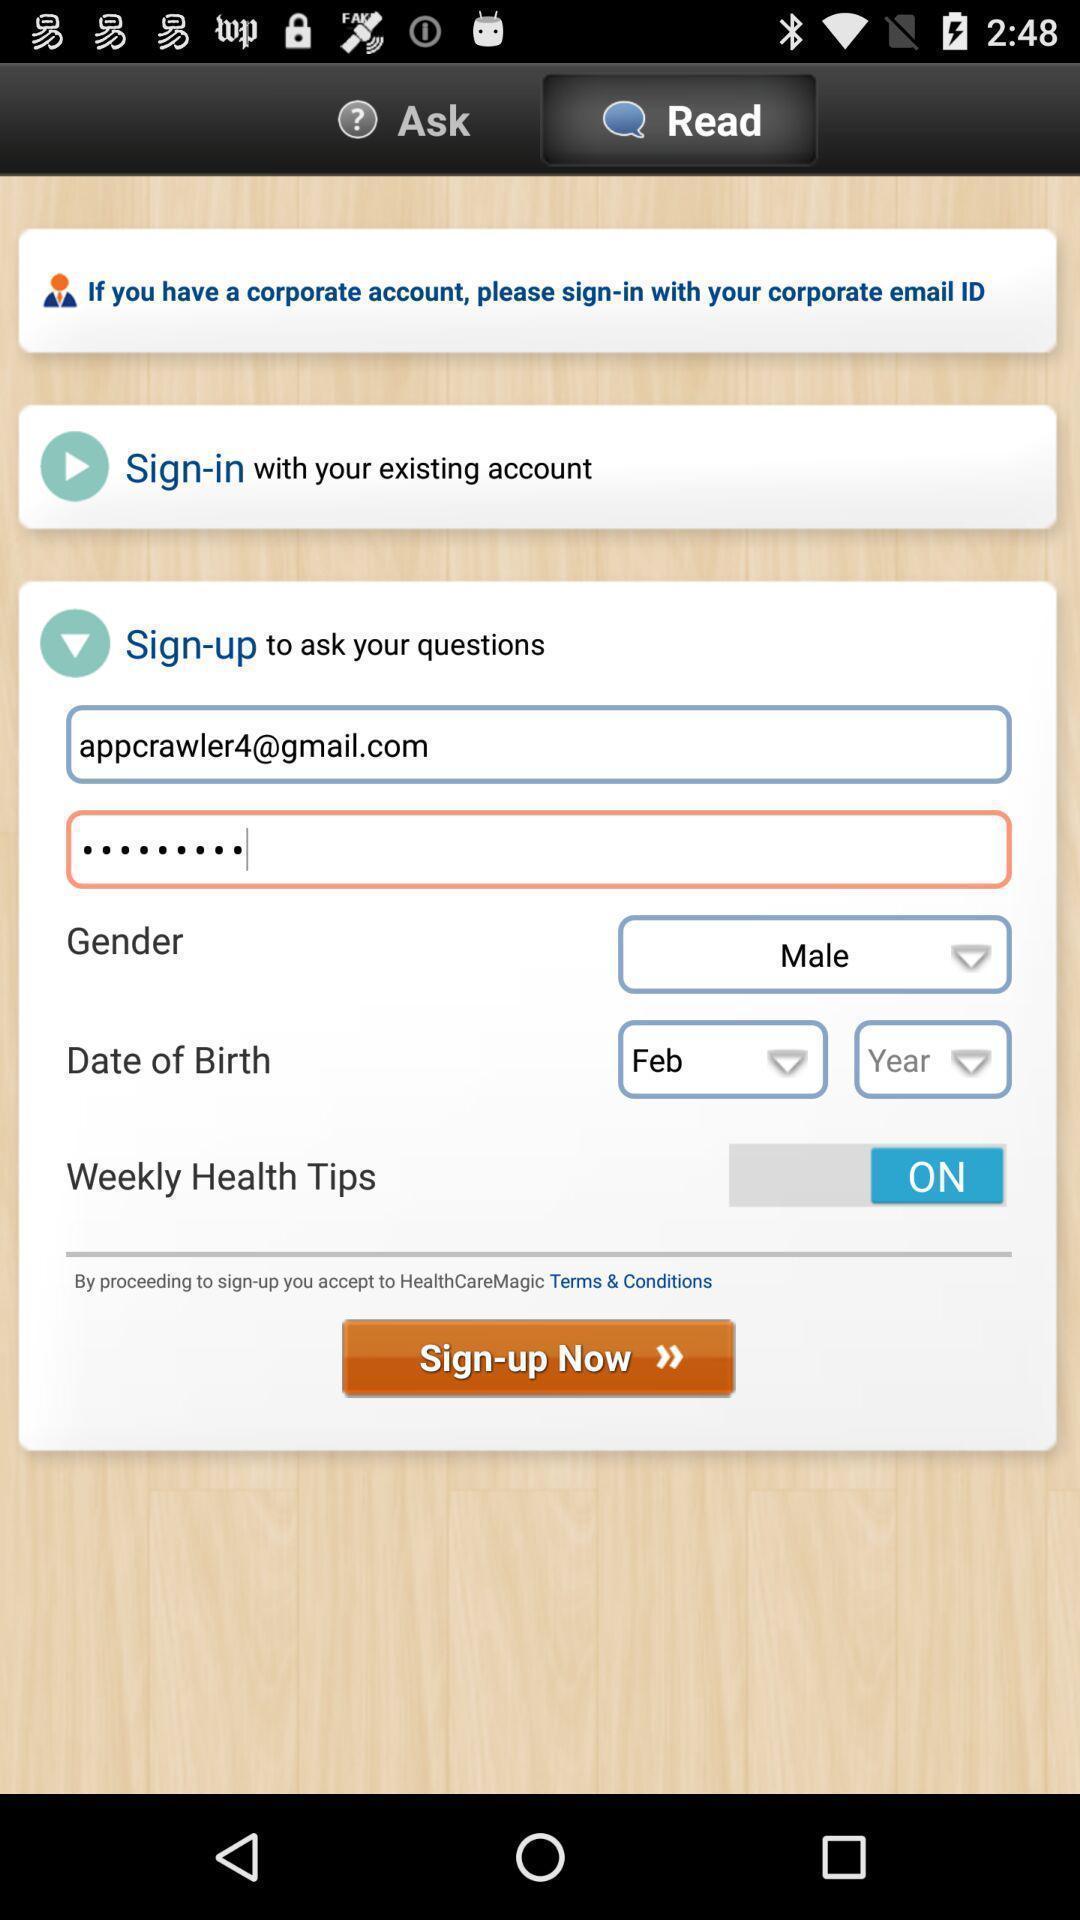Explain what's happening in this screen capture. Welcome to the sign up page. 